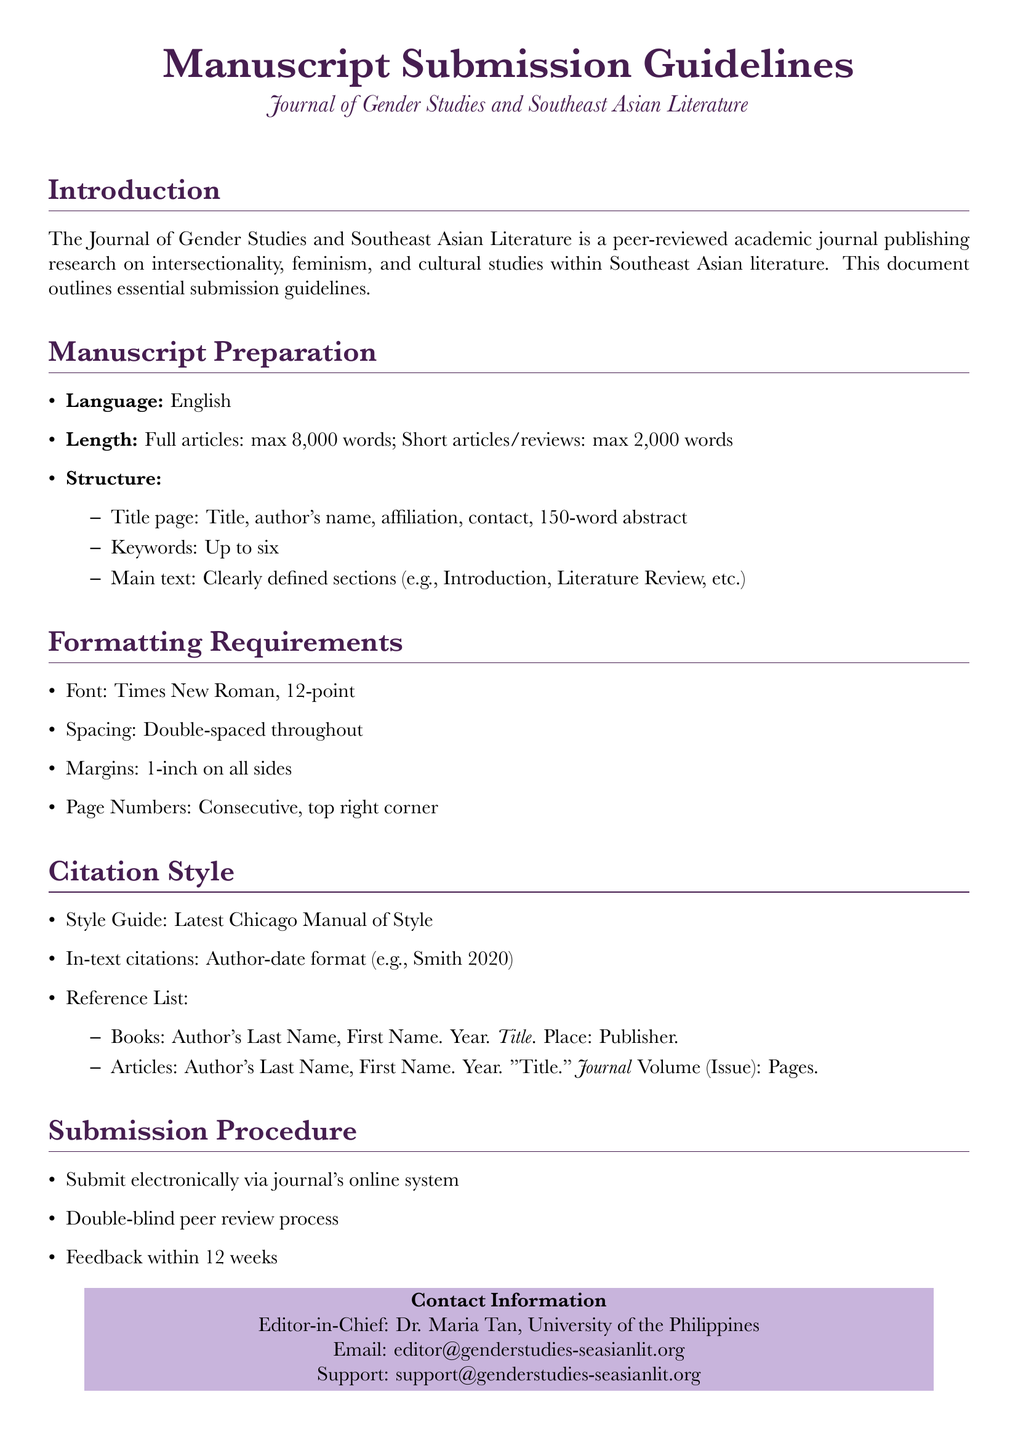What is the maximum word length for full articles? The document states that full articles have a maximum length of 8,000 words.
Answer: 8,000 words What is the font size requirement for manuscripts? The guidelines specify a font size of 12-point for manuscripts.
Answer: 12-point Who is the Editor-in-Chief? The document lists Dr. Maria Tan as the Editor-in-Chief.
Answer: Dr. Maria Tan What citation style should be used? It is required to use the latest Chicago Manual of Style for citations.
Answer: Chicago Manual of Style What is the submission process type mentioned in the document? The document indicates that the submission will undergo a double-blind peer review process.
Answer: double-blind peer review How many keywords should be included in the manuscript? Authors are instructed to include up to six keywords.
Answer: six What is the contact email for support? The document provides support email as support@genderstudies-seasianlit.org.
Answer: support@genderstudies-seasianlit.org What is the required spacing throughout the manuscript? The guidelines specify that the manuscript should be double-spaced throughout.
Answer: double-spaced What is the feedback timeframe after submission? The document mentions feedback will be provided within 12 weeks.
Answer: 12 weeks 